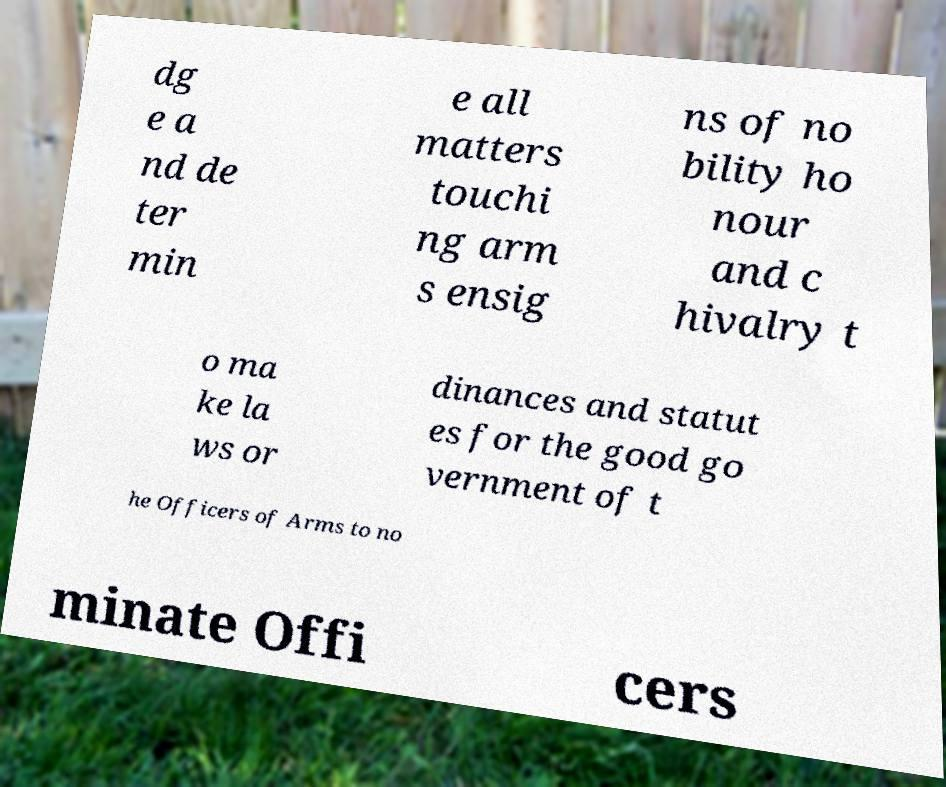I need the written content from this picture converted into text. Can you do that? dg e a nd de ter min e all matters touchi ng arm s ensig ns of no bility ho nour and c hivalry t o ma ke la ws or dinances and statut es for the good go vernment of t he Officers of Arms to no minate Offi cers 